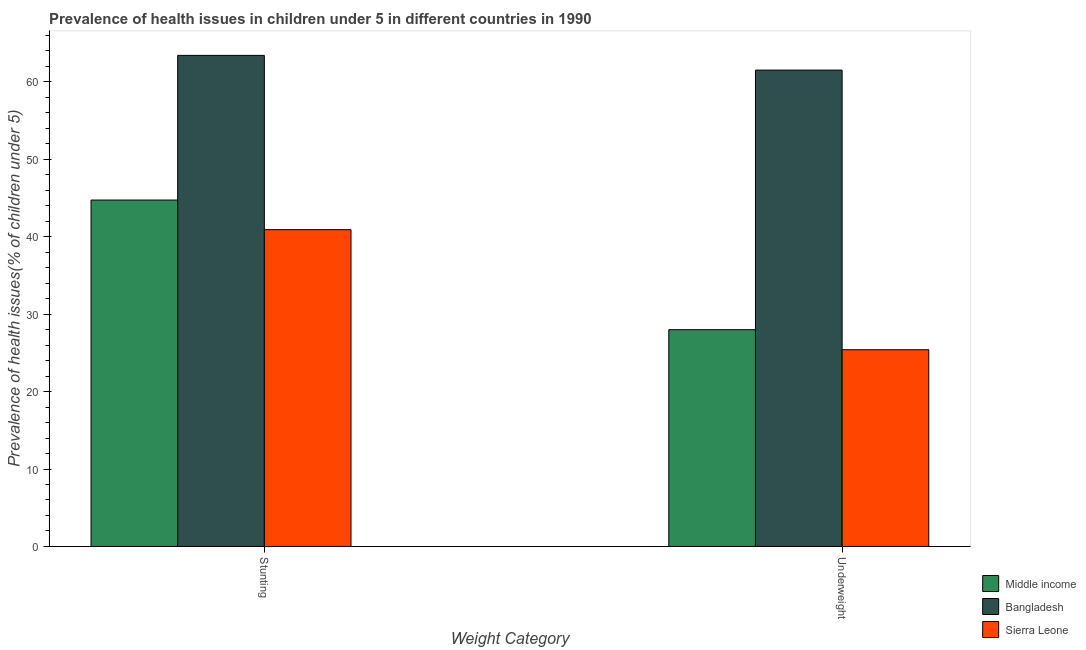How many groups of bars are there?
Offer a terse response. 2. Are the number of bars on each tick of the X-axis equal?
Make the answer very short. Yes. How many bars are there on the 2nd tick from the left?
Your answer should be compact. 3. How many bars are there on the 2nd tick from the right?
Provide a succinct answer. 3. What is the label of the 2nd group of bars from the left?
Offer a terse response. Underweight. What is the percentage of stunted children in Bangladesh?
Provide a short and direct response. 63.4. Across all countries, what is the maximum percentage of stunted children?
Ensure brevity in your answer.  63.4. Across all countries, what is the minimum percentage of underweight children?
Offer a terse response. 25.4. In which country was the percentage of stunted children minimum?
Offer a very short reply. Sierra Leone. What is the total percentage of underweight children in the graph?
Offer a terse response. 114.89. What is the difference between the percentage of stunted children in Bangladesh and that in Middle income?
Give a very brief answer. 18.68. What is the difference between the percentage of underweight children in Middle income and the percentage of stunted children in Sierra Leone?
Your answer should be compact. -12.91. What is the average percentage of underweight children per country?
Provide a short and direct response. 38.3. What is the difference between the percentage of stunted children and percentage of underweight children in Sierra Leone?
Your answer should be very brief. 15.5. In how many countries, is the percentage of underweight children greater than 4 %?
Make the answer very short. 3. What is the ratio of the percentage of underweight children in Bangladesh to that in Middle income?
Make the answer very short. 2.2. Is the percentage of underweight children in Middle income less than that in Sierra Leone?
Provide a succinct answer. No. What does the 3rd bar from the left in Underweight represents?
Provide a short and direct response. Sierra Leone. What does the 1st bar from the right in Underweight represents?
Your answer should be very brief. Sierra Leone. How many bars are there?
Offer a very short reply. 6. How many countries are there in the graph?
Offer a terse response. 3. Does the graph contain any zero values?
Offer a very short reply. No. Does the graph contain grids?
Keep it short and to the point. No. Where does the legend appear in the graph?
Your answer should be very brief. Bottom right. How many legend labels are there?
Your answer should be very brief. 3. How are the legend labels stacked?
Offer a very short reply. Vertical. What is the title of the graph?
Give a very brief answer. Prevalence of health issues in children under 5 in different countries in 1990. What is the label or title of the X-axis?
Make the answer very short. Weight Category. What is the label or title of the Y-axis?
Offer a terse response. Prevalence of health issues(% of children under 5). What is the Prevalence of health issues(% of children under 5) of Middle income in Stunting?
Make the answer very short. 44.72. What is the Prevalence of health issues(% of children under 5) in Bangladesh in Stunting?
Your response must be concise. 63.4. What is the Prevalence of health issues(% of children under 5) of Sierra Leone in Stunting?
Offer a very short reply. 40.9. What is the Prevalence of health issues(% of children under 5) in Middle income in Underweight?
Keep it short and to the point. 27.99. What is the Prevalence of health issues(% of children under 5) in Bangladesh in Underweight?
Your response must be concise. 61.5. What is the Prevalence of health issues(% of children under 5) in Sierra Leone in Underweight?
Make the answer very short. 25.4. Across all Weight Category, what is the maximum Prevalence of health issues(% of children under 5) in Middle income?
Your answer should be compact. 44.72. Across all Weight Category, what is the maximum Prevalence of health issues(% of children under 5) of Bangladesh?
Provide a short and direct response. 63.4. Across all Weight Category, what is the maximum Prevalence of health issues(% of children under 5) of Sierra Leone?
Provide a short and direct response. 40.9. Across all Weight Category, what is the minimum Prevalence of health issues(% of children under 5) in Middle income?
Give a very brief answer. 27.99. Across all Weight Category, what is the minimum Prevalence of health issues(% of children under 5) of Bangladesh?
Make the answer very short. 61.5. Across all Weight Category, what is the minimum Prevalence of health issues(% of children under 5) of Sierra Leone?
Your response must be concise. 25.4. What is the total Prevalence of health issues(% of children under 5) in Middle income in the graph?
Provide a succinct answer. 72.71. What is the total Prevalence of health issues(% of children under 5) in Bangladesh in the graph?
Keep it short and to the point. 124.9. What is the total Prevalence of health issues(% of children under 5) of Sierra Leone in the graph?
Your response must be concise. 66.3. What is the difference between the Prevalence of health issues(% of children under 5) in Middle income in Stunting and that in Underweight?
Your answer should be compact. 16.74. What is the difference between the Prevalence of health issues(% of children under 5) in Middle income in Stunting and the Prevalence of health issues(% of children under 5) in Bangladesh in Underweight?
Provide a succinct answer. -16.78. What is the difference between the Prevalence of health issues(% of children under 5) in Middle income in Stunting and the Prevalence of health issues(% of children under 5) in Sierra Leone in Underweight?
Your answer should be compact. 19.32. What is the average Prevalence of health issues(% of children under 5) in Middle income per Weight Category?
Keep it short and to the point. 36.35. What is the average Prevalence of health issues(% of children under 5) in Bangladesh per Weight Category?
Ensure brevity in your answer.  62.45. What is the average Prevalence of health issues(% of children under 5) of Sierra Leone per Weight Category?
Give a very brief answer. 33.15. What is the difference between the Prevalence of health issues(% of children under 5) in Middle income and Prevalence of health issues(% of children under 5) in Bangladesh in Stunting?
Provide a short and direct response. -18.68. What is the difference between the Prevalence of health issues(% of children under 5) in Middle income and Prevalence of health issues(% of children under 5) in Sierra Leone in Stunting?
Provide a succinct answer. 3.82. What is the difference between the Prevalence of health issues(% of children under 5) of Bangladesh and Prevalence of health issues(% of children under 5) of Sierra Leone in Stunting?
Your response must be concise. 22.5. What is the difference between the Prevalence of health issues(% of children under 5) in Middle income and Prevalence of health issues(% of children under 5) in Bangladesh in Underweight?
Keep it short and to the point. -33.51. What is the difference between the Prevalence of health issues(% of children under 5) in Middle income and Prevalence of health issues(% of children under 5) in Sierra Leone in Underweight?
Keep it short and to the point. 2.59. What is the difference between the Prevalence of health issues(% of children under 5) of Bangladesh and Prevalence of health issues(% of children under 5) of Sierra Leone in Underweight?
Offer a terse response. 36.1. What is the ratio of the Prevalence of health issues(% of children under 5) in Middle income in Stunting to that in Underweight?
Make the answer very short. 1.6. What is the ratio of the Prevalence of health issues(% of children under 5) in Bangladesh in Stunting to that in Underweight?
Your response must be concise. 1.03. What is the ratio of the Prevalence of health issues(% of children under 5) of Sierra Leone in Stunting to that in Underweight?
Your answer should be compact. 1.61. What is the difference between the highest and the second highest Prevalence of health issues(% of children under 5) of Middle income?
Offer a very short reply. 16.74. What is the difference between the highest and the lowest Prevalence of health issues(% of children under 5) in Middle income?
Give a very brief answer. 16.74. What is the difference between the highest and the lowest Prevalence of health issues(% of children under 5) of Sierra Leone?
Your response must be concise. 15.5. 